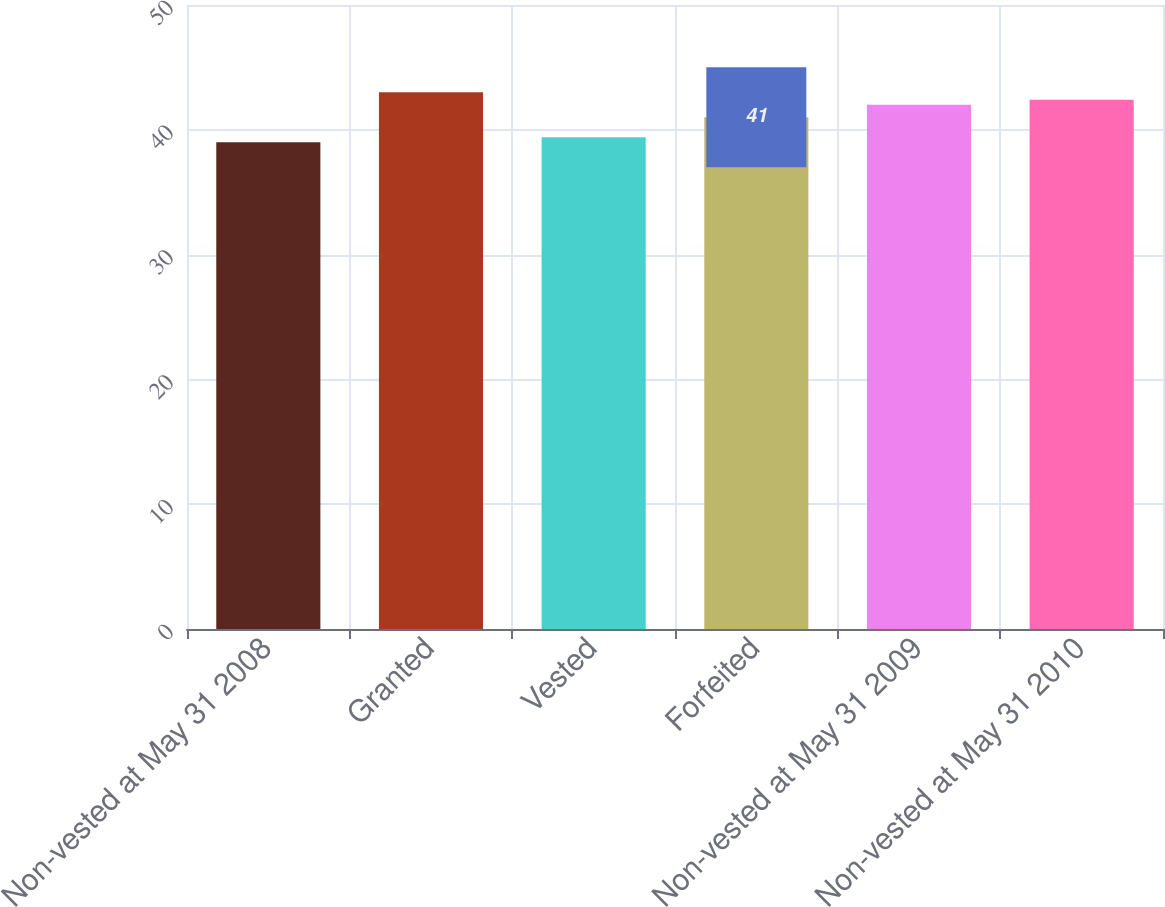Convert chart. <chart><loc_0><loc_0><loc_500><loc_500><bar_chart><fcel>Non-vested at May 31 2008<fcel>Granted<fcel>Vested<fcel>Forfeited<fcel>Non-vested at May 31 2009<fcel>Non-vested at May 31 2010<nl><fcel>39<fcel>43<fcel>39.4<fcel>41<fcel>42<fcel>42.4<nl></chart> 